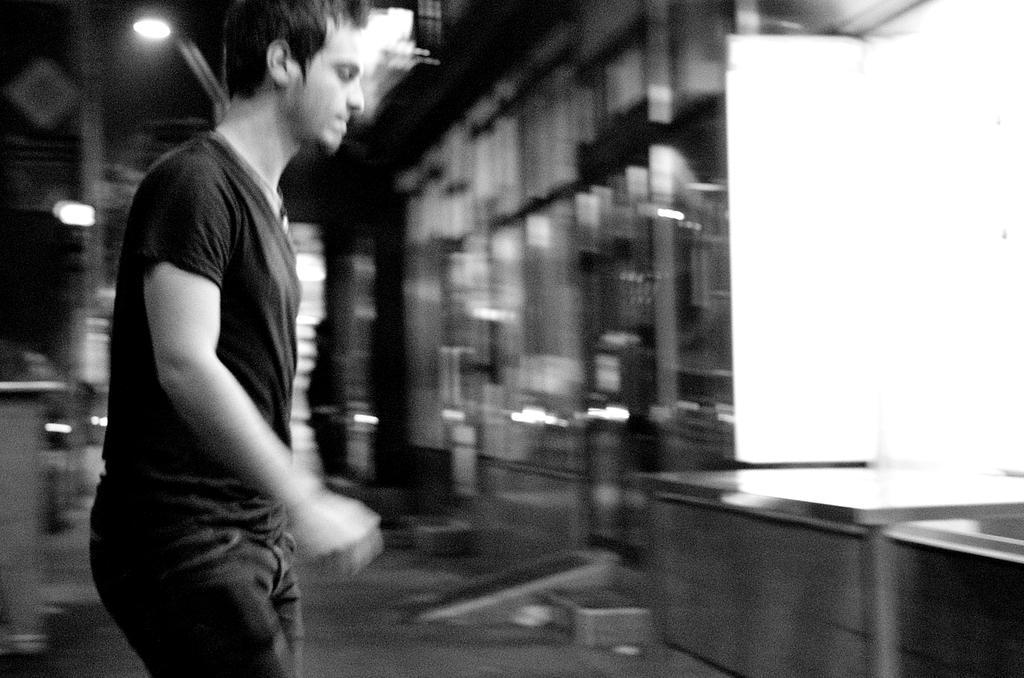Please provide a concise description of this image. It is a black and white picture,a man is standing he is wearing black shirt it seems to be there is a window in front of him,in the background it looks like a factory,to the roof there are some of lights. 